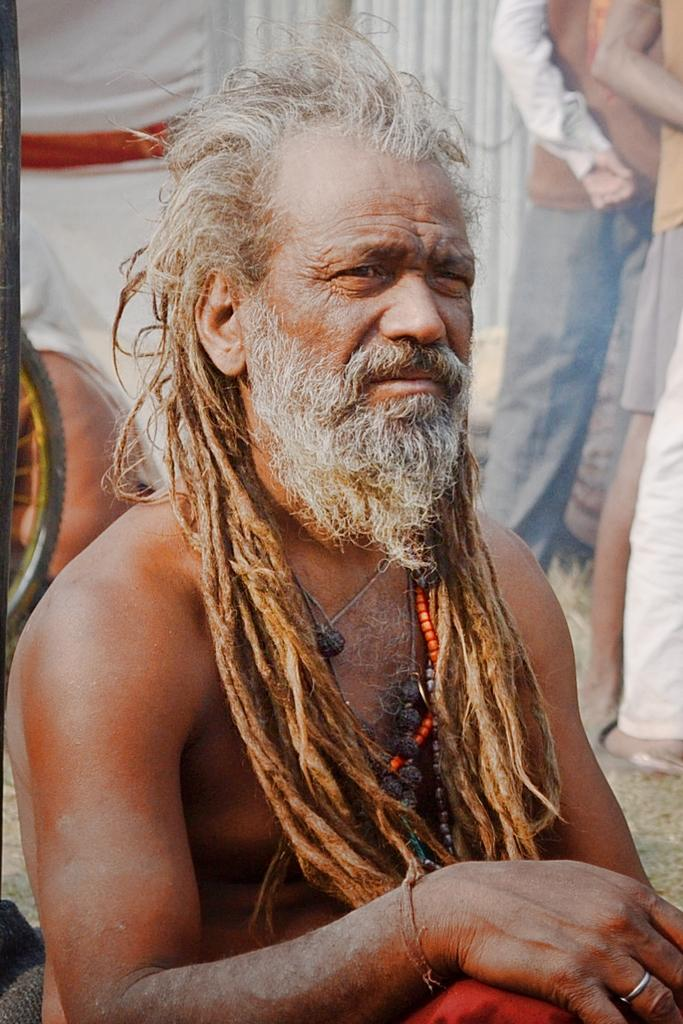Who or what is present in the image? There is a person in the image. What object can be seen on the left side of the image? There is a wheel on the left side of the image. How many people are visible in the background of the image? There are three people visible in the background of the image. Is the person in the image using magic to move the wheel? There is no indication of magic being used in the image; the person and the wheel are stationary. 